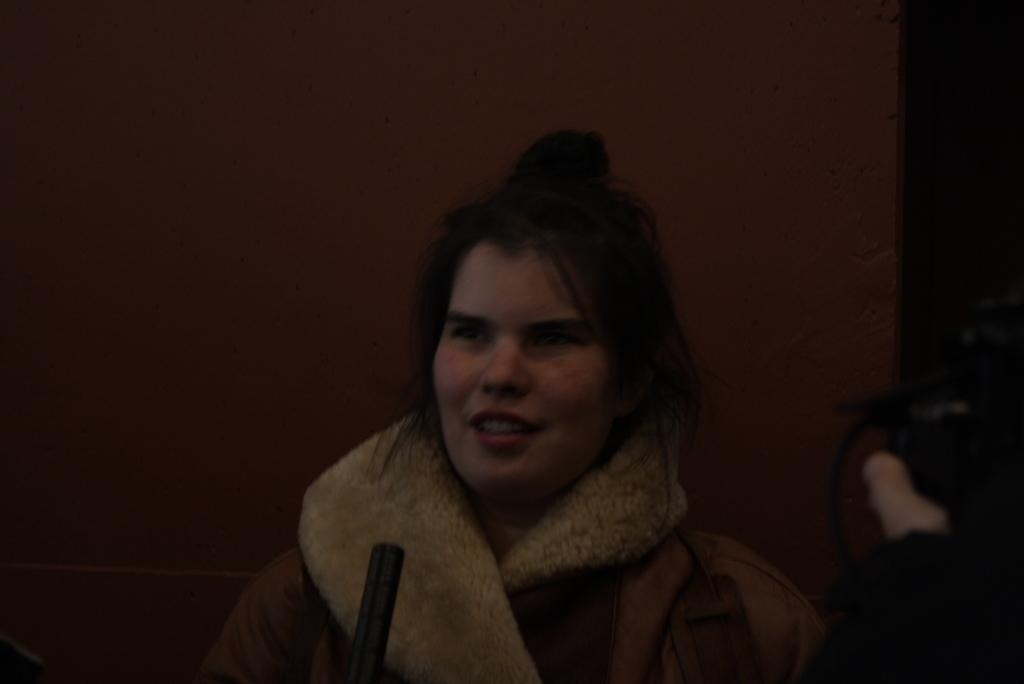What is present in the background of the image? There is a wall in the image. Can you describe the person in the image? There is a woman standing in the front of the image. What type of event is taking place in the image? There is no indication of an event taking place in the image; it only shows a woman standing in front of a wall. Can you tell me how much salt is on the woman's hand in the image? There is no salt present in the image, so it is not possible to determine the amount on the woman's hand. 